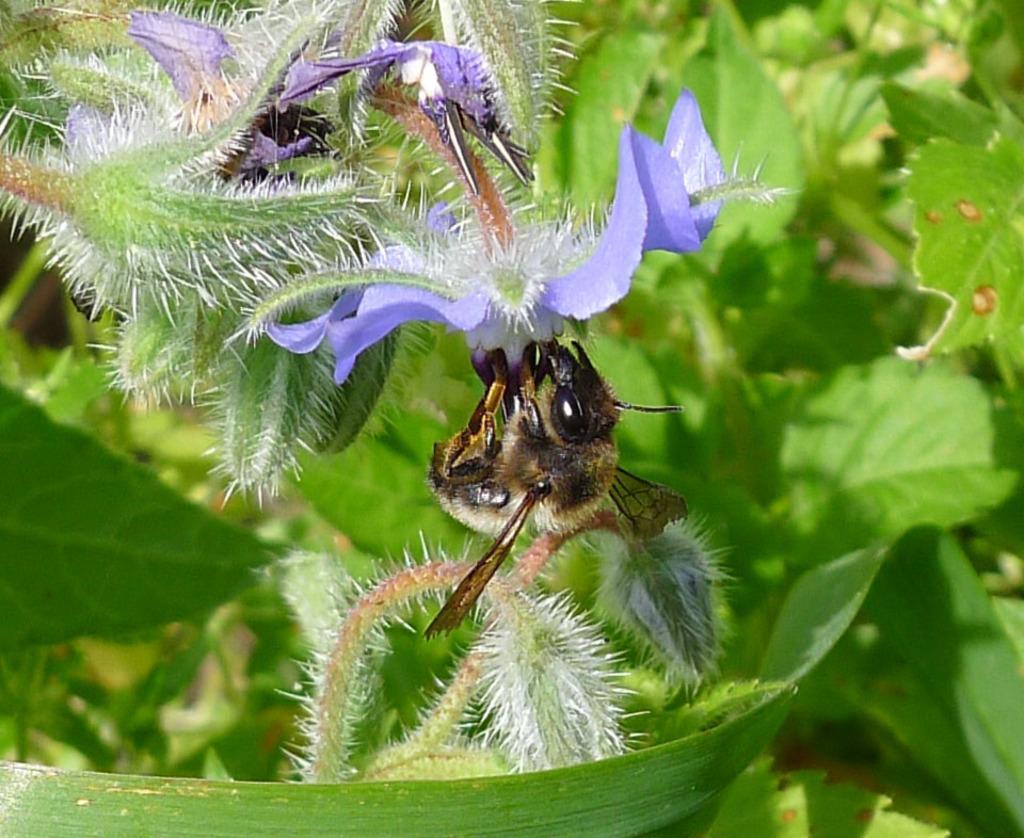Describe this image in one or two sentences. In the picture I can see an insect on an object and there are few leaves in the background. 